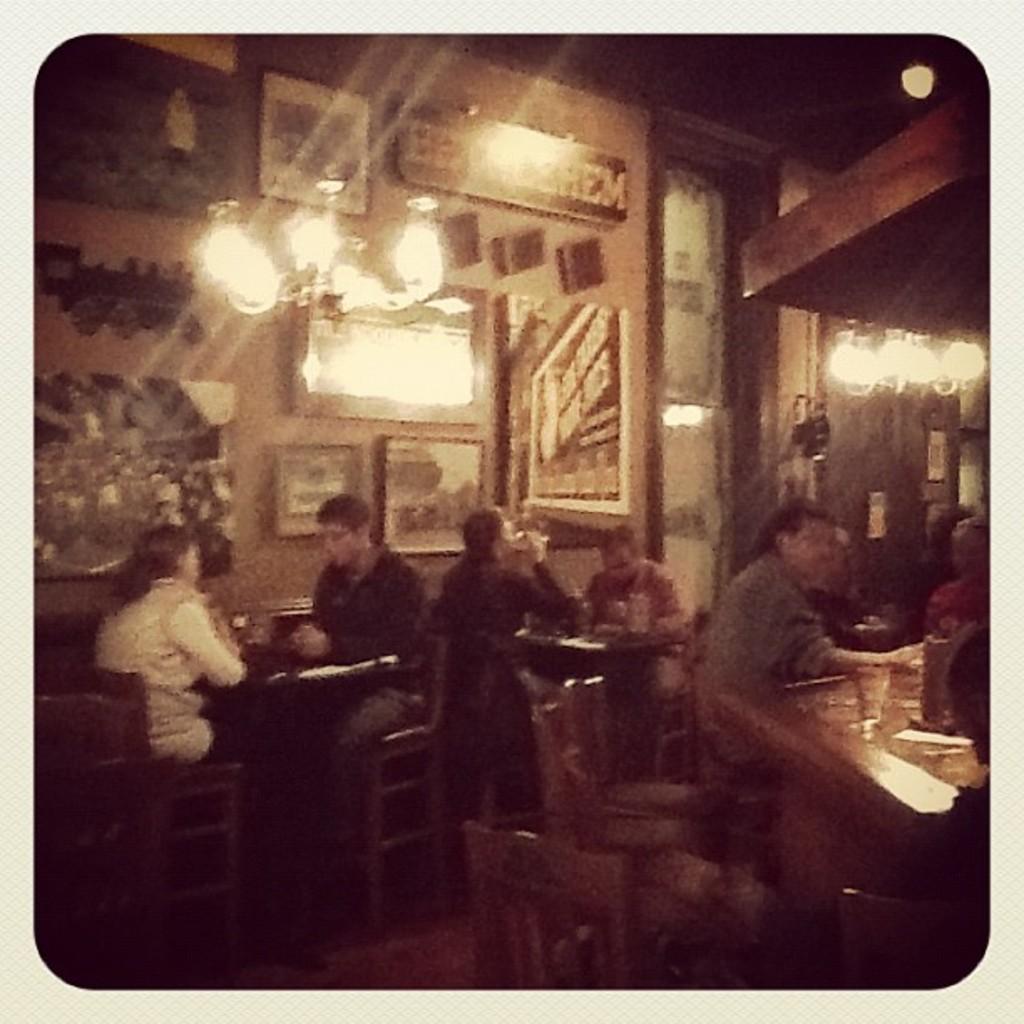In one or two sentences, can you explain what this image depicts? Different type of pictures on wall. On top there are lights. Persons are sitting on a chair. In-front of them there are tables. 